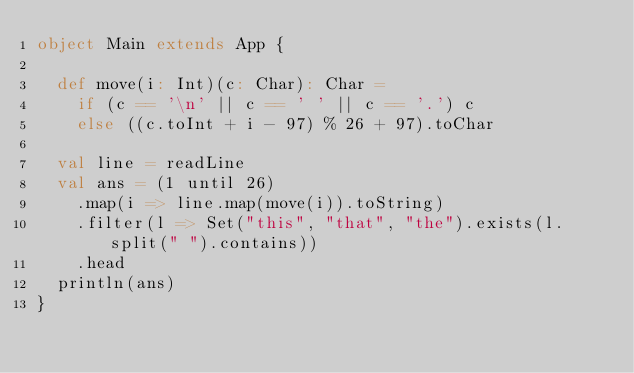Convert code to text. <code><loc_0><loc_0><loc_500><loc_500><_Scala_>object Main extends App {

  def move(i: Int)(c: Char): Char =
    if (c == '\n' || c == ' ' || c == '.') c
    else ((c.toInt + i - 97) % 26 + 97).toChar

  val line = readLine
  val ans = (1 until 26)
    .map(i => line.map(move(i)).toString)
    .filter(l => Set("this", "that", "the").exists(l.split(" ").contains))
    .head
  println(ans)
}
</code> 